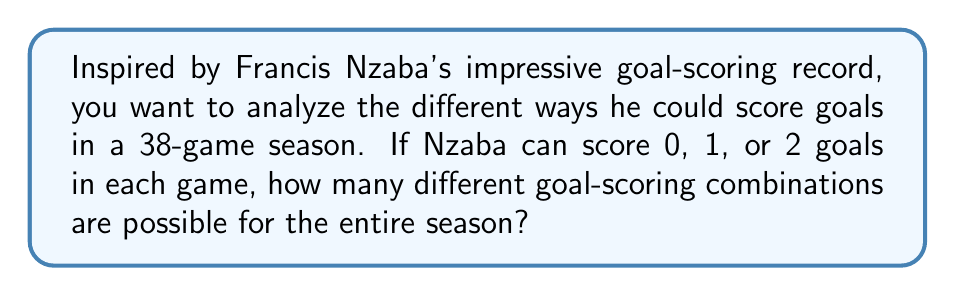Show me your answer to this math problem. Let's approach this step-by-step:

1) For each game, Nzaba has 3 possible outcomes: 0 goals, 1 goal, or 2 goals.

2) This scenario repeats for each of the 38 games in the season.

3) This is a perfect setup for using the multiplication principle in combinatorics.

4) The multiplication principle states that if we have $n$ independent events, and each event $i$ has $k_i$ possible outcomes, then the total number of possible outcomes for all events is the product of the number of outcomes for each event.

5) In this case, we have 38 independent events (games), and each event has 3 possible outcomes.

6) Therefore, the total number of possible goal-scoring combinations is:

   $$3 \times 3 \times 3 \times ... \times 3$$ (38 times)

7) This can be written as an exponent:

   $$3^{38}$$

8) Calculating this:

   $$3^{38} = 1,552,518,092,300,764,000$$

This enormous number represents all possible goal-scoring combinations for Nzaba over the 38-game season, ranging from scoring no goals at all to scoring 2 goals in every single game.
Answer: $3^{38}$ 